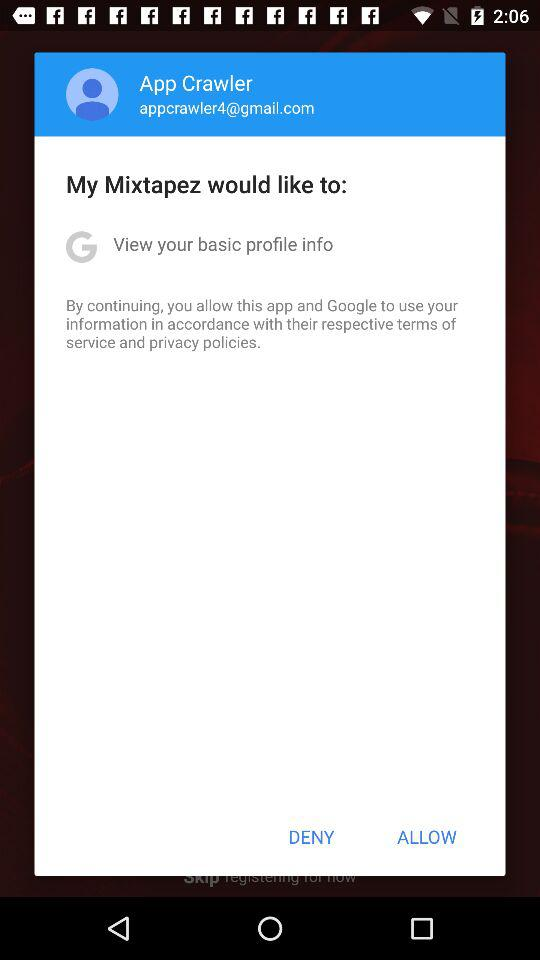What is the Gmail address? The Gmail address is appcrawler4@gmail.com. 